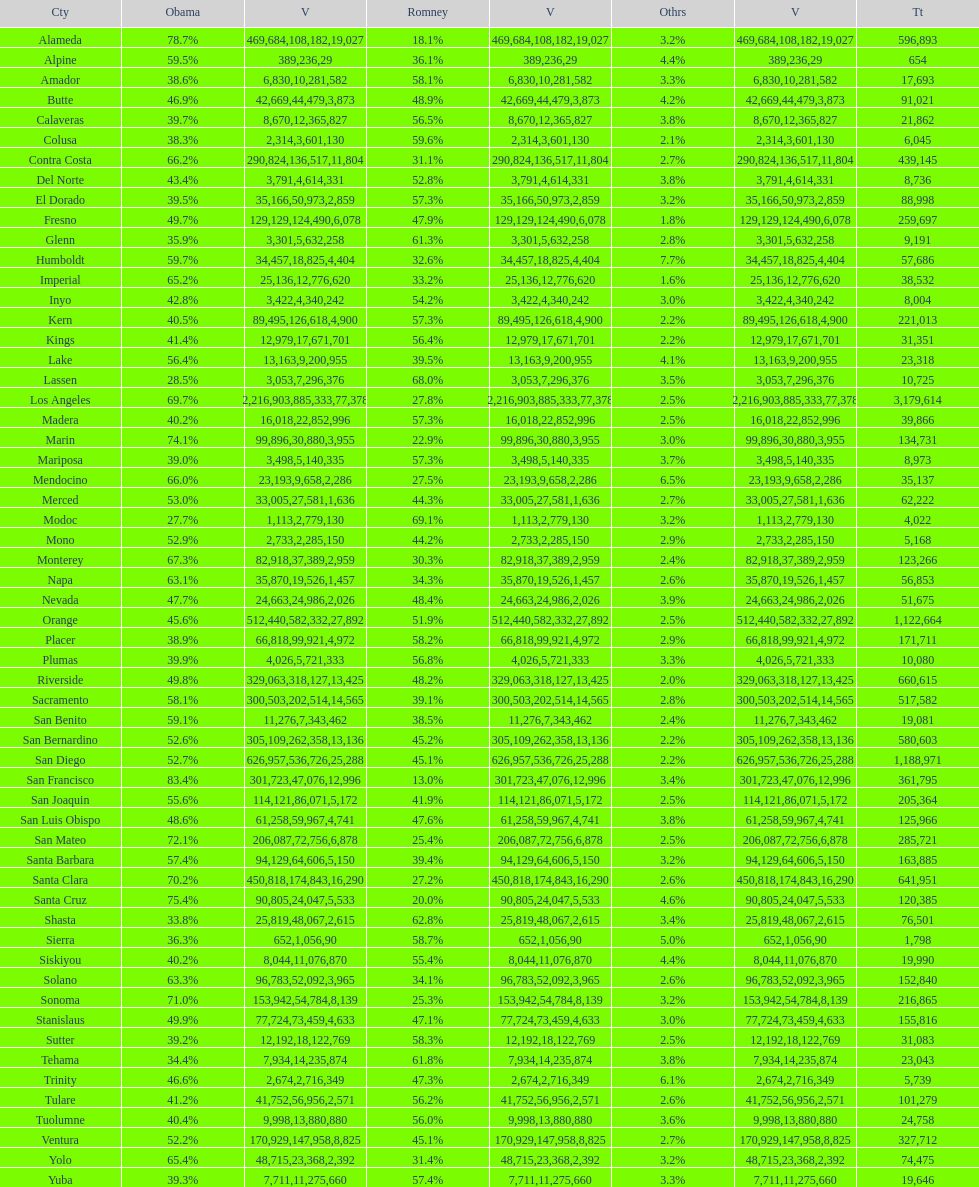Did romney earn more or less votes than obama did in alameda county? Less. 